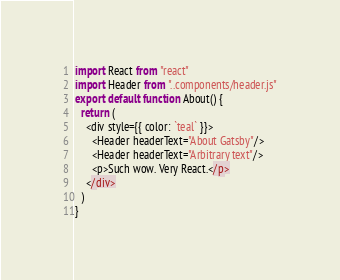<code> <loc_0><loc_0><loc_500><loc_500><_JavaScript_>import React from "react"
import Header from "..components/header.js"
export default function About() {
  return (
    <div style={{ color: `teal` }}>
      <Header headerText="About Gatsby"/>
      <Header headerText="Arbitrary text"/>
      <p>Such wow. Very React.</p>
    </div>
  )
}</code> 